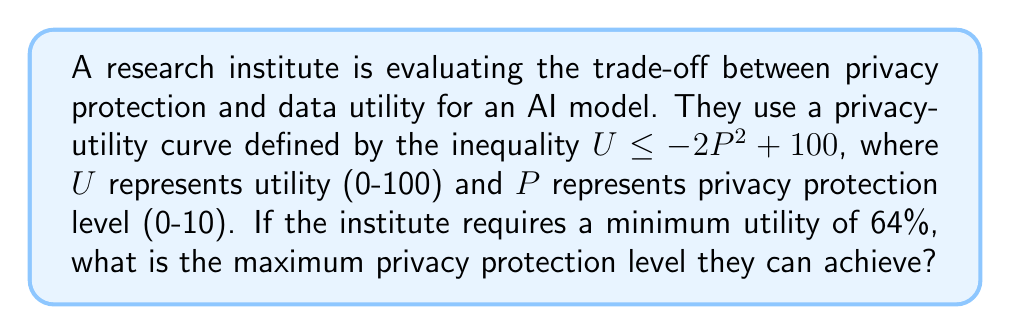Solve this math problem. To solve this problem, we need to follow these steps:

1) The privacy-utility curve is defined by the inequality:
   $U \leq -2P^2 + 100$

2) We're told that the minimum utility required is 64%. Let's substitute this into our inequality:
   $64 \leq -2P^2 + 100$

3) Now, we want to solve this for P. First, let's subtract 100 from both sides:
   $-36 \leq -2P^2$

4) Divide both sides by -2:
   $18 \geq P^2$

5) Take the square root of both sides. Since P represents a protection level, it can't be negative, so we only consider the positive root:
   $\sqrt{18} \geq P$

6) Simplify the square root:
   $3\sqrt{2} \geq P$

7) $3\sqrt{2}$ is approximately 4.24, which is the maximum value for P that satisfies our inequality.
Answer: $3\sqrt{2}$ (approximately 4.24) 